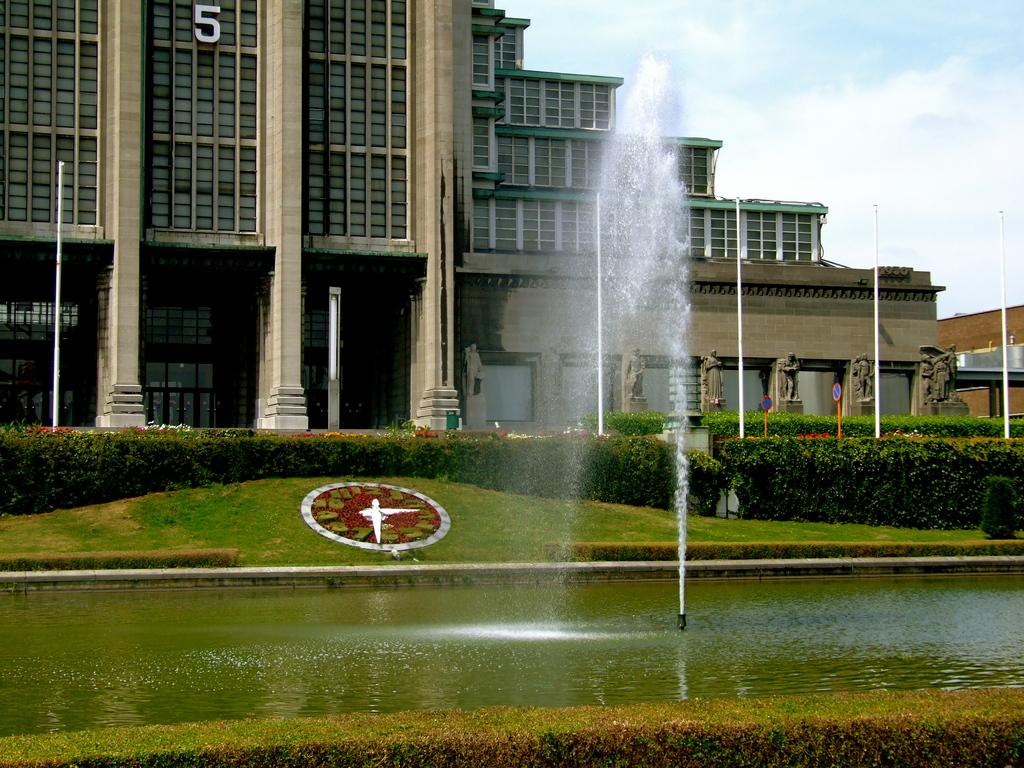What type of structures can be seen in the image? There are buildings in the image. What other objects are present in the image? There are poles, pillars, statues, and a fountain visible in the image. What can be seen in the sky in the image? The sky with clouds is visible in the image. What type of vegetation is present in the image? There are bushes in the image. What decorative elements can be seen in the image? There is decor in the image. Is there any water visible in the image? Yes, there is water visible in the image. What type of ground is visible in the image? The ground is visible in the image. Can you tell me how many clovers are growing in the image? There are no clovers present in the image. Is there a family gathering in the image? There is no indication of a family gathering in the image. What type of tools does the carpenter have in the image? There is no carpenter present in the image. 